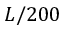<formula> <loc_0><loc_0><loc_500><loc_500>L / 2 0 0</formula> 